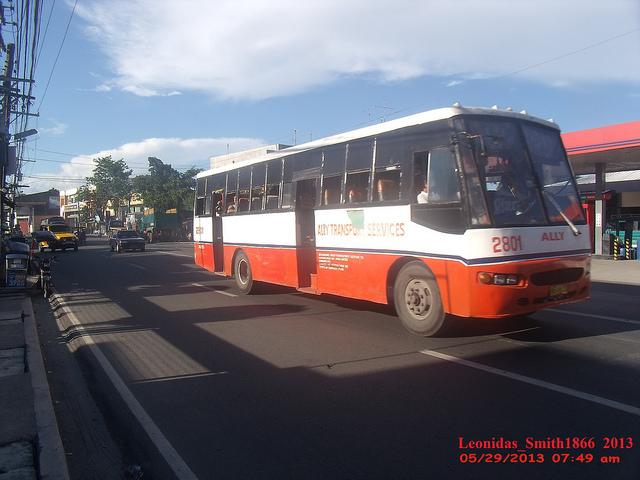Why is the bus parked along the side of the road?
Be succinct. Riding. How many people can fit on this bus?
Write a very short answer. 50. Are the bus lights on?
Give a very brief answer. No. What color is the bus?
Quick response, please. White and orange. What color is the bottom of the bus?
Keep it brief. Orange. Is it sunny?
Keep it brief. Yes. Is the bus in motion?
Concise answer only. Yes. 